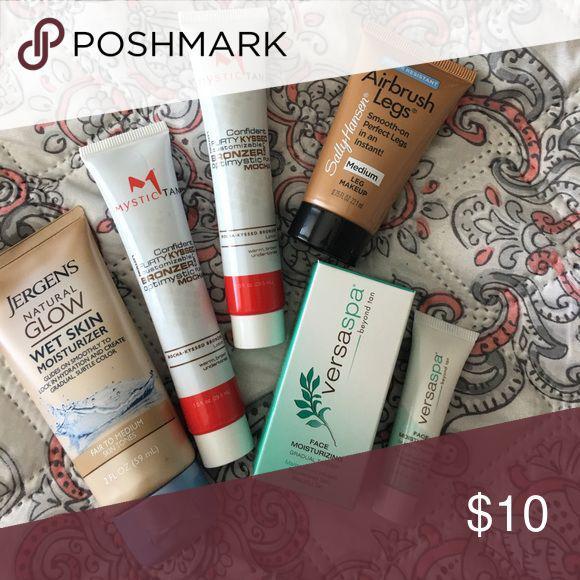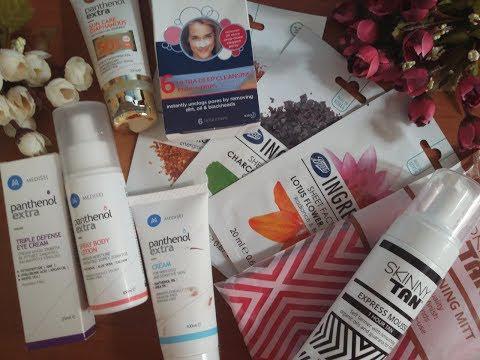The first image is the image on the left, the second image is the image on the right. For the images shown, is this caption "An image includes multiple stacks of short silver containers with labels on top, and with only one unlidded." true? Answer yes or no. No. The first image is the image on the left, the second image is the image on the right. Analyze the images presented: Is the assertion "The lotion in one of the images is sitting in round tin containers." valid? Answer yes or no. No. 